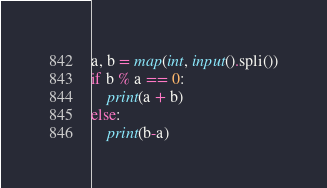Convert code to text. <code><loc_0><loc_0><loc_500><loc_500><_Python_>a, b = map(int, input().spli())
if b % a == 0:
    print(a + b)
else:
    print(b-a)</code> 